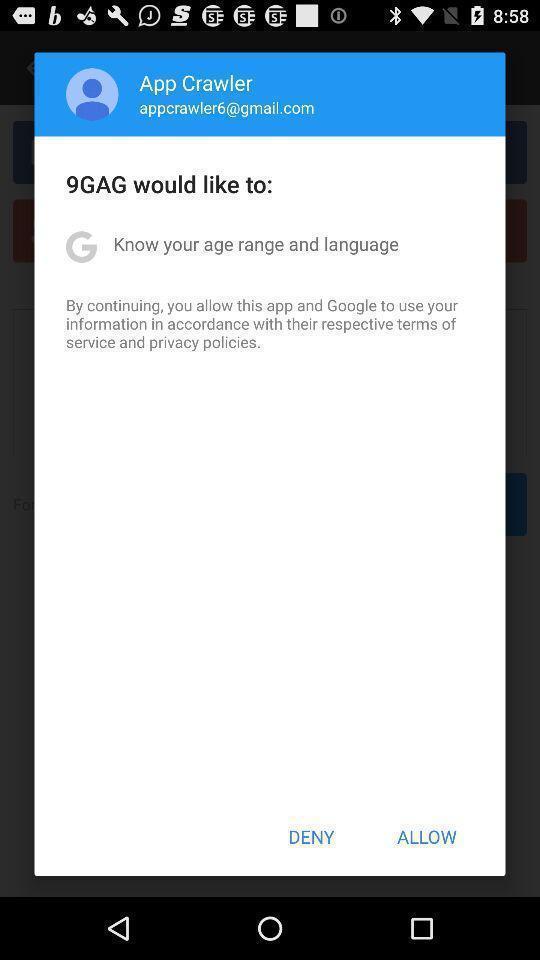What details can you identify in this image? Pop up page showing the declaration information. 